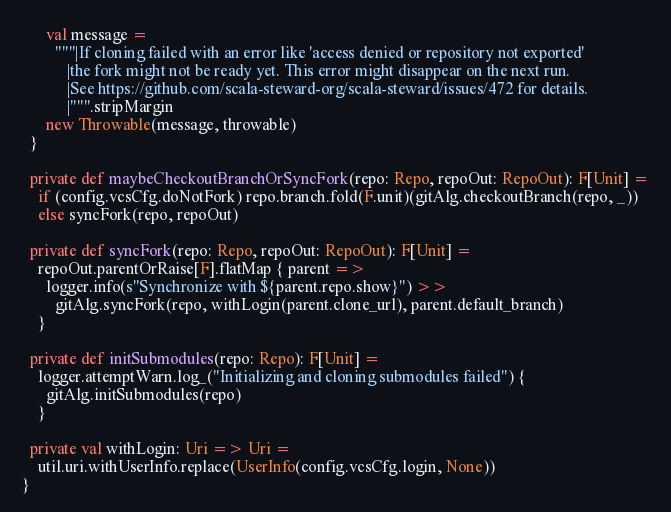<code> <loc_0><loc_0><loc_500><loc_500><_Scala_>      val message =
        """|If cloning failed with an error like 'access denied or repository not exported'
           |the fork might not be ready yet. This error might disappear on the next run.
           |See https://github.com/scala-steward-org/scala-steward/issues/472 for details.
           |""".stripMargin
      new Throwable(message, throwable)
  }

  private def maybeCheckoutBranchOrSyncFork(repo: Repo, repoOut: RepoOut): F[Unit] =
    if (config.vcsCfg.doNotFork) repo.branch.fold(F.unit)(gitAlg.checkoutBranch(repo, _))
    else syncFork(repo, repoOut)

  private def syncFork(repo: Repo, repoOut: RepoOut): F[Unit] =
    repoOut.parentOrRaise[F].flatMap { parent =>
      logger.info(s"Synchronize with ${parent.repo.show}") >>
        gitAlg.syncFork(repo, withLogin(parent.clone_url), parent.default_branch)
    }

  private def initSubmodules(repo: Repo): F[Unit] =
    logger.attemptWarn.log_("Initializing and cloning submodules failed") {
      gitAlg.initSubmodules(repo)
    }

  private val withLogin: Uri => Uri =
    util.uri.withUserInfo.replace(UserInfo(config.vcsCfg.login, None))
}
</code> 